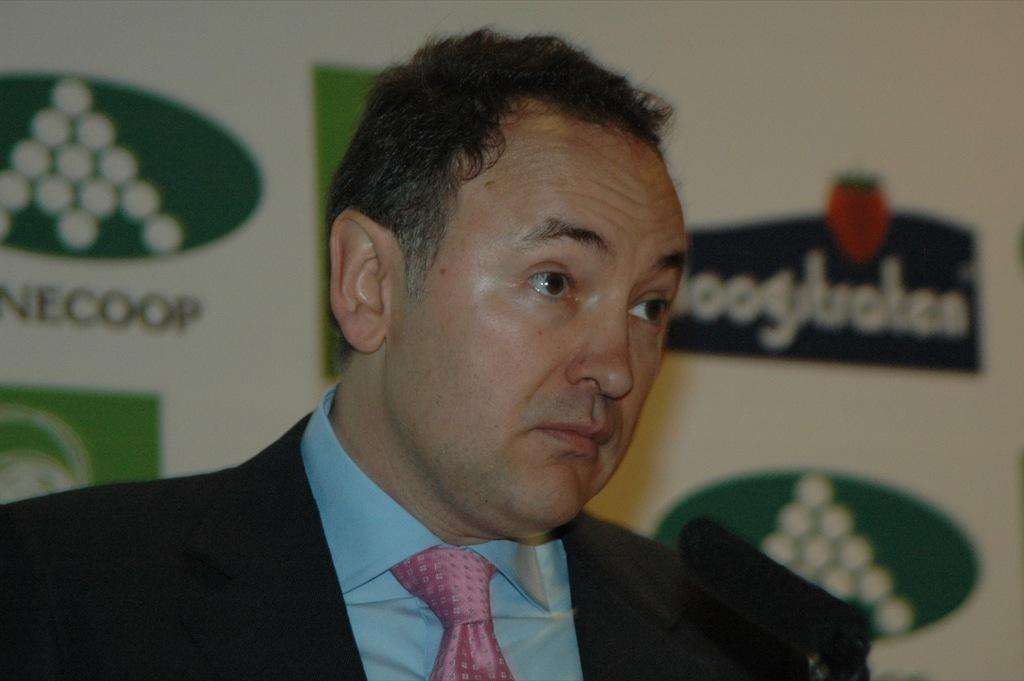Who is present in the image? There is a man in the image. What is the man wearing? The man is wearing a coat, a shirt, and a tie. What object is in front of the man? There is a mic in front of the man. What can be seen in the background of the image? There is a poster in the background of the image. How many rabbits are hopping around the man in the image? There are no rabbits present in the image. What type of tramp is visible in the image? There is no tramp present in the image. 